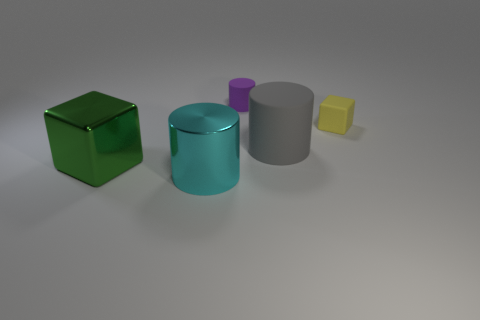Is the size of the gray cylinder the same as the cube left of the tiny purple thing?
Give a very brief answer. Yes. Are there any cubes that have the same color as the big matte cylinder?
Your answer should be very brief. No. The cylinder that is made of the same material as the green block is what size?
Provide a short and direct response. Large. Is the big green block made of the same material as the big cyan cylinder?
Your response must be concise. Yes. There is a big thing to the right of the cylinder that is on the left side of the matte object that is left of the gray cylinder; what color is it?
Your answer should be compact. Gray. There is a small purple rubber thing; what shape is it?
Offer a terse response. Cylinder. Does the metallic block have the same color as the tiny object to the left of the big rubber cylinder?
Keep it short and to the point. No. Is the number of cyan objects that are right of the large rubber cylinder the same as the number of purple objects?
Your answer should be very brief. No. What number of other cubes are the same size as the yellow matte block?
Your response must be concise. 0. Is there a big green metal cylinder?
Your response must be concise. No. 